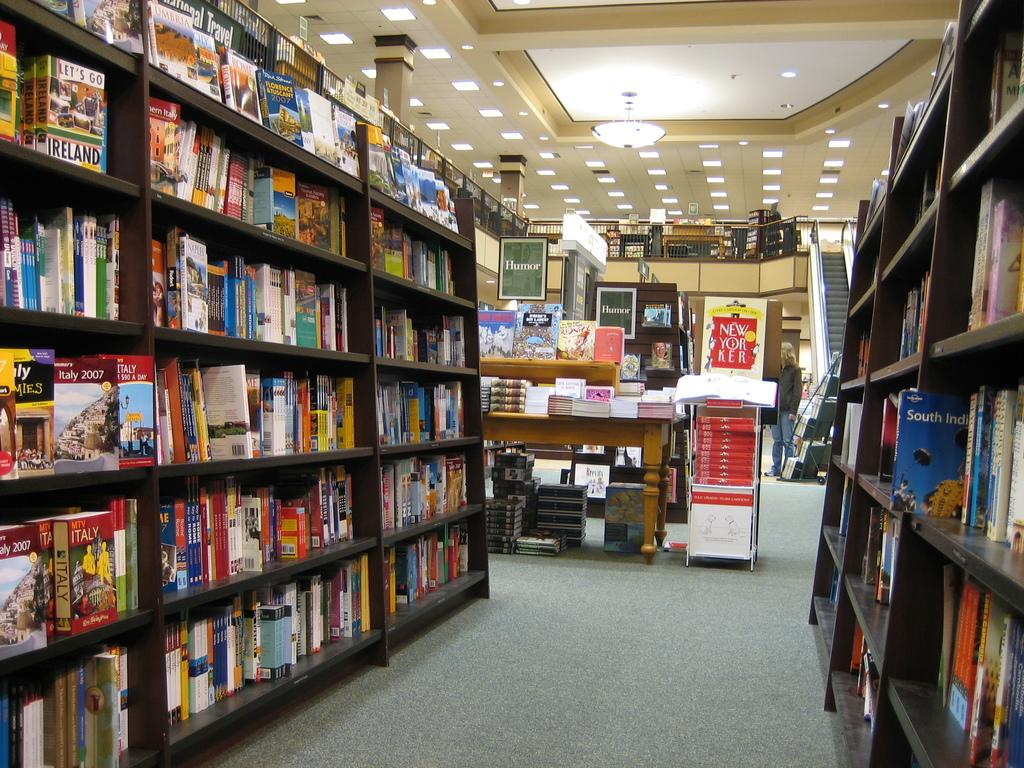<image>
Present a compact description of the photo's key features. Library with a book titled "Let's Go Ireland" on the shelf. 